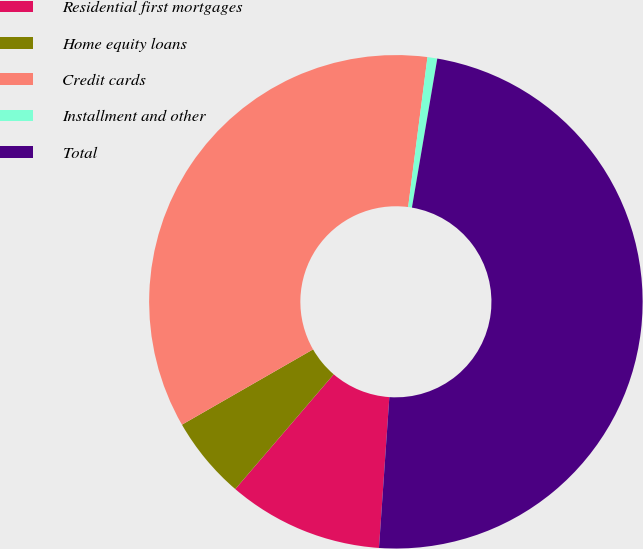<chart> <loc_0><loc_0><loc_500><loc_500><pie_chart><fcel>Residential first mortgages<fcel>Home equity loans<fcel>Credit cards<fcel>Installment and other<fcel>Total<nl><fcel>10.19%<fcel>5.42%<fcel>35.34%<fcel>0.64%<fcel>48.41%<nl></chart> 